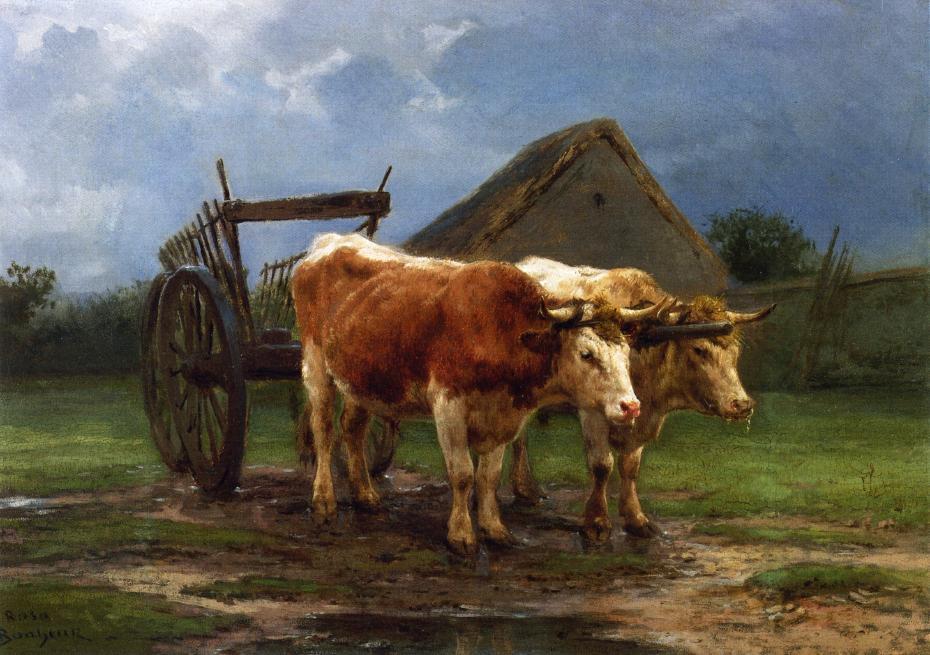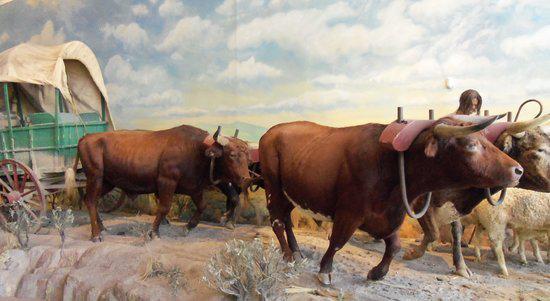The first image is the image on the left, the second image is the image on the right. Assess this claim about the two images: "In the image to the left we've got two work-animals.". Correct or not? Answer yes or no. Yes. The first image is the image on the left, the second image is the image on the right. Considering the images on both sides, is "An image shows all brown oxen hitched to a green covered wagon with red wheels and aimed rightward." valid? Answer yes or no. Yes. 